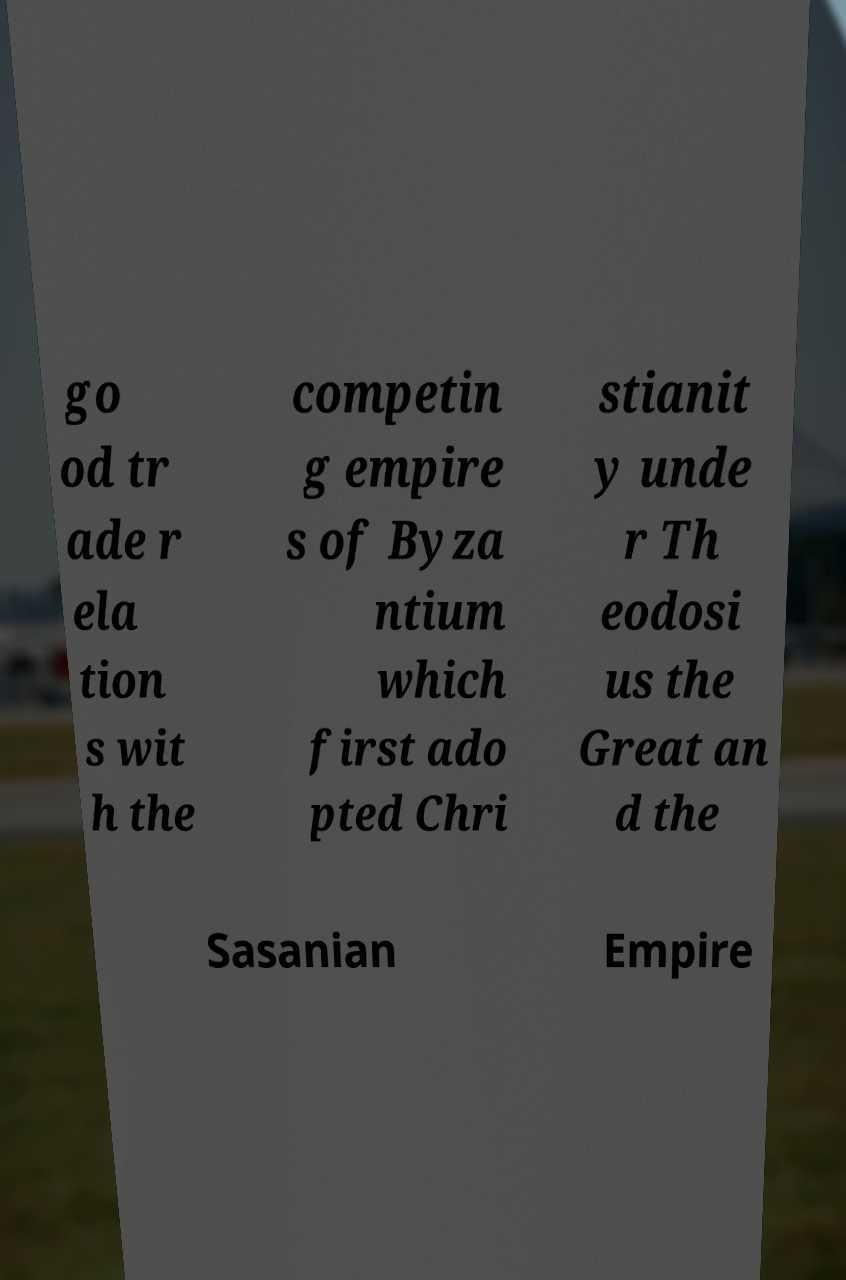Please read and relay the text visible in this image. What does it say? go od tr ade r ela tion s wit h the competin g empire s of Byza ntium which first ado pted Chri stianit y unde r Th eodosi us the Great an d the Sasanian Empire 